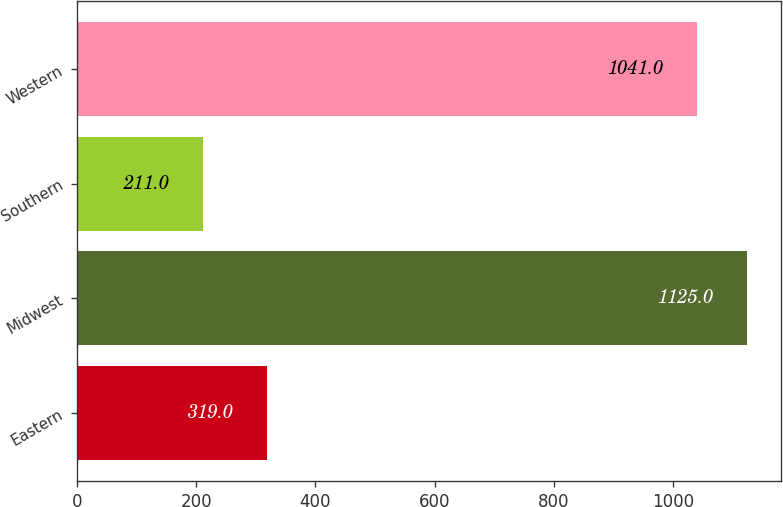Convert chart to OTSL. <chart><loc_0><loc_0><loc_500><loc_500><bar_chart><fcel>Eastern<fcel>Midwest<fcel>Southern<fcel>Western<nl><fcel>319<fcel>1125<fcel>211<fcel>1041<nl></chart> 